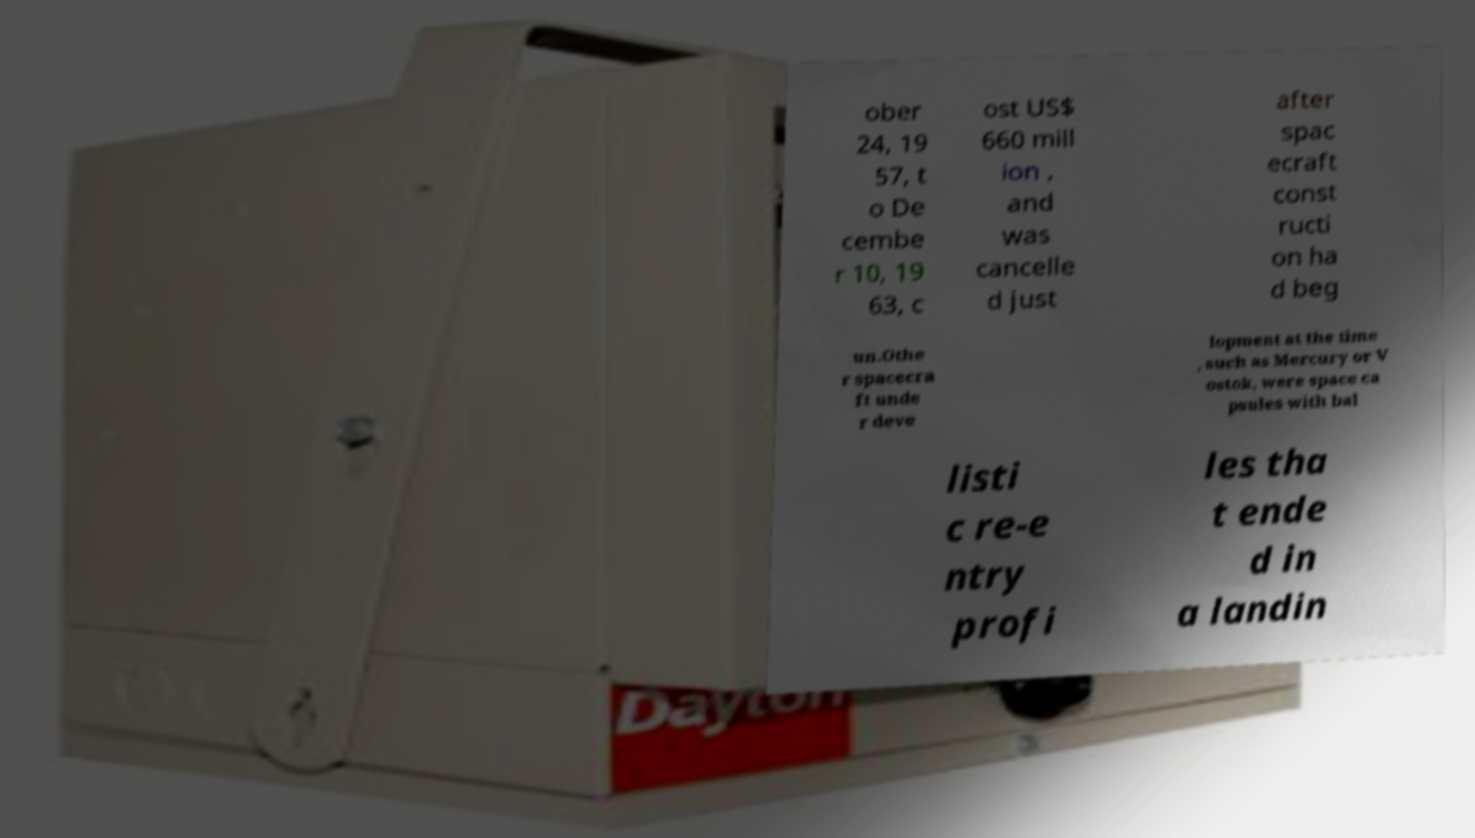There's text embedded in this image that I need extracted. Can you transcribe it verbatim? ober 24, 19 57, t o De cembe r 10, 19 63, c ost US$ 660 mill ion , and was cancelle d just after spac ecraft const ructi on ha d beg un.Othe r spacecra ft unde r deve lopment at the time , such as Mercury or V ostok, were space ca psules with bal listi c re-e ntry profi les tha t ende d in a landin 